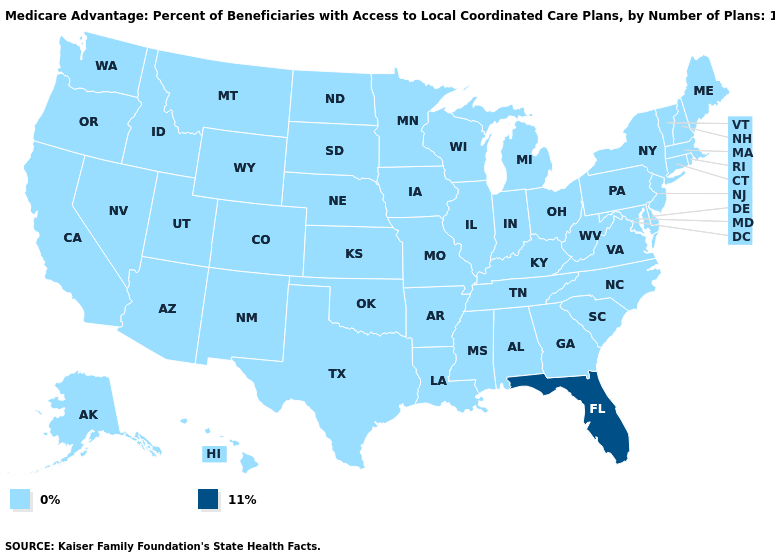What is the value of California?
Quick response, please. 0%. What is the highest value in states that border Oregon?
Answer briefly. 0%. Name the states that have a value in the range 11%?
Short answer required. Florida. What is the value of Tennessee?
Be succinct. 0%. Name the states that have a value in the range 0%?
Be succinct. Alaska, Alabama, Arkansas, Arizona, California, Colorado, Connecticut, Delaware, Georgia, Hawaii, Iowa, Idaho, Illinois, Indiana, Kansas, Kentucky, Louisiana, Massachusetts, Maryland, Maine, Michigan, Minnesota, Missouri, Mississippi, Montana, North Carolina, North Dakota, Nebraska, New Hampshire, New Jersey, New Mexico, Nevada, New York, Ohio, Oklahoma, Oregon, Pennsylvania, Rhode Island, South Carolina, South Dakota, Tennessee, Texas, Utah, Virginia, Vermont, Washington, Wisconsin, West Virginia, Wyoming. What is the lowest value in states that border Oregon?
Short answer required. 0%. How many symbols are there in the legend?
Answer briefly. 2. What is the value of Nebraska?
Be succinct. 0%. Among the states that border Arizona , which have the lowest value?
Give a very brief answer. California, Colorado, New Mexico, Nevada, Utah. Does the map have missing data?
Quick response, please. No. What is the lowest value in the West?
Answer briefly. 0%. What is the highest value in the USA?
Quick response, please. 11%. What is the lowest value in the USA?
Write a very short answer. 0%. Name the states that have a value in the range 0%?
Answer briefly. Alaska, Alabama, Arkansas, Arizona, California, Colorado, Connecticut, Delaware, Georgia, Hawaii, Iowa, Idaho, Illinois, Indiana, Kansas, Kentucky, Louisiana, Massachusetts, Maryland, Maine, Michigan, Minnesota, Missouri, Mississippi, Montana, North Carolina, North Dakota, Nebraska, New Hampshire, New Jersey, New Mexico, Nevada, New York, Ohio, Oklahoma, Oregon, Pennsylvania, Rhode Island, South Carolina, South Dakota, Tennessee, Texas, Utah, Virginia, Vermont, Washington, Wisconsin, West Virginia, Wyoming. 